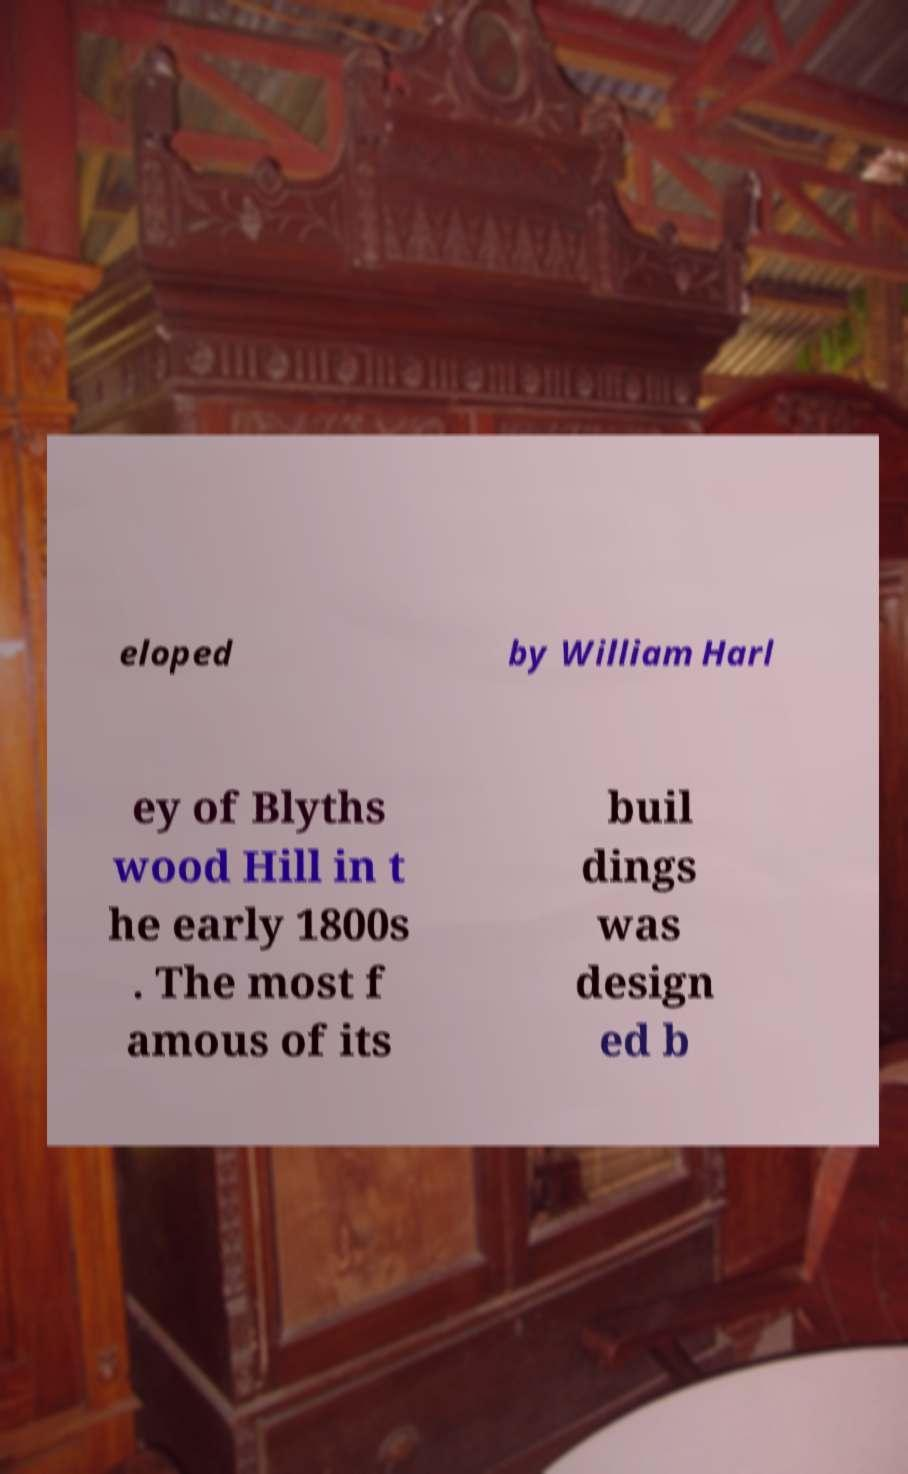Could you extract and type out the text from this image? eloped by William Harl ey of Blyths wood Hill in t he early 1800s . The most f amous of its buil dings was design ed b 